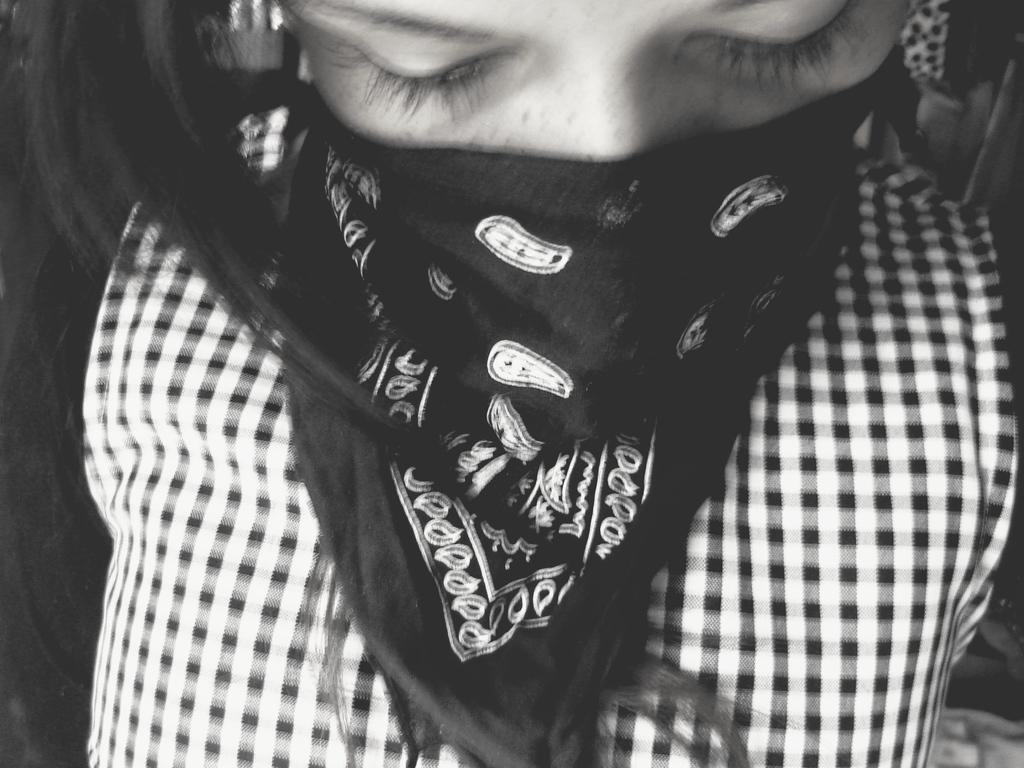Who is the main subject in the picture? There is a girl in the picture. What is the girl doing with her face? The girl is covering her face with a black cloth. How can you describe the girl's clothing? The girl is wearing checkered clothes. What scent can be detected from the girl's mouth in the image? There is no information about the scent of the girl's mouth in the image. 